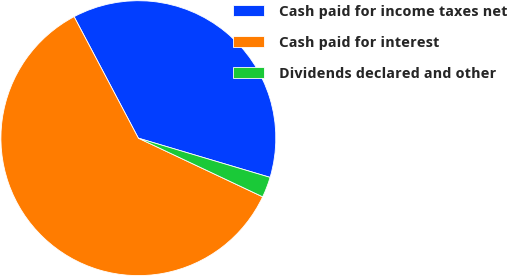Convert chart. <chart><loc_0><loc_0><loc_500><loc_500><pie_chart><fcel>Cash paid for income taxes net<fcel>Cash paid for interest<fcel>Dividends declared and other<nl><fcel>37.35%<fcel>60.24%<fcel>2.41%<nl></chart> 